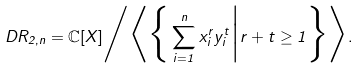Convert formula to latex. <formula><loc_0><loc_0><loc_500><loc_500>\ D R _ { 2 , n } = \mathbb { C } [ X ] \Big / \Big \langle \Big \{ \sum _ { i = 1 } ^ { n } x _ { i } ^ { r } y _ { i } ^ { t } \Big | r + t \geq 1 \Big \} \Big \rangle .</formula> 